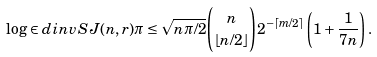Convert formula to latex. <formula><loc_0><loc_0><loc_500><loc_500>\log \in d i n v S { J ( n , r ) } { \pi } \leq \sqrt { n \pi / 2 } \binom { n } { \lfloor n / 2 \rfloor } 2 ^ { - \lceil m / 2 \rceil } \left ( 1 + \frac { 1 } { 7 n } \right ) .</formula> 